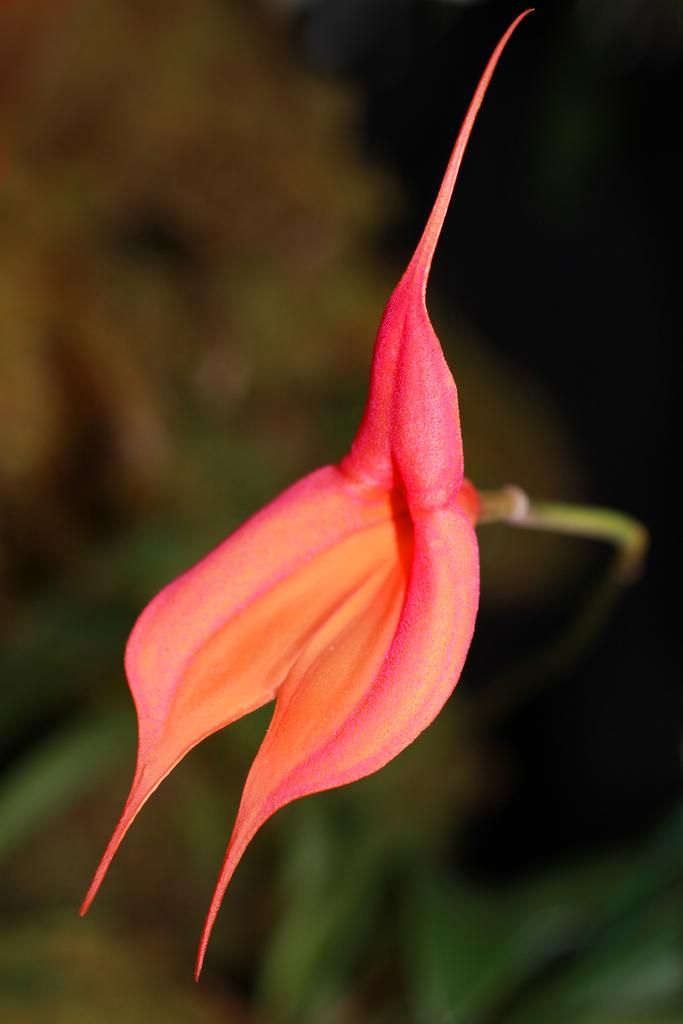What can be seen in the image? There is an object in the image. Can you describe the appearance of the object? The object is in orange and pink color and is attached to a stem. How is the background of the image depicted? The backdrop of the image is slightly blurred. How many yaks are visible in the image? There are no yaks present in the image. Is there a bike being used by the object in the image? There is no bike present in the image. 